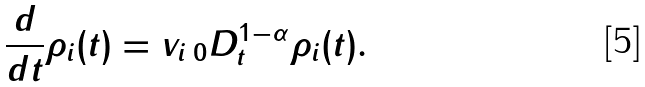<formula> <loc_0><loc_0><loc_500><loc_500>\frac { d } { d t } \rho _ { i } ( t ) = v _ { i } \, _ { 0 } D _ { t } ^ { 1 - \alpha } \rho _ { i } ( t ) .</formula> 